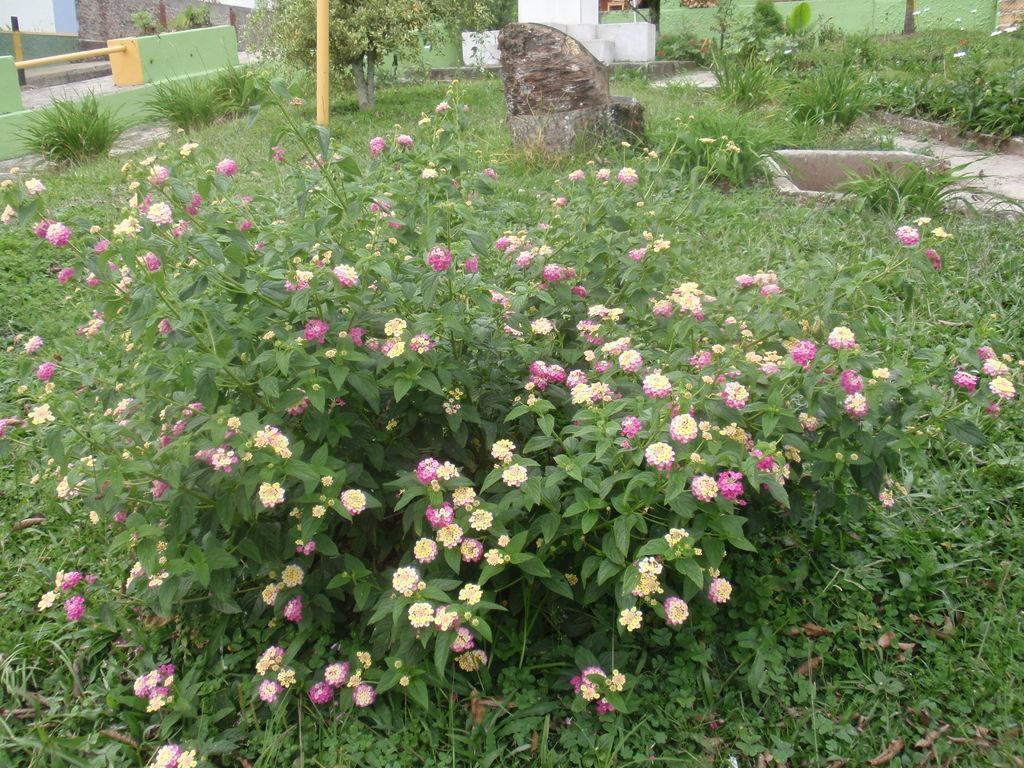What types of vegetation can be seen in the front of the image? There are plants and flowers in the front of the image. What is visible in the background of the image? There is a wall in the background of the image. What can be found in the middle of the image? There is a pole in the middle of the image. Where is the rod located in the image? The rod is on the left side of the image. How many fingers can be seen holding the apple in the image? There is no apple or fingers present in the image. Is the door open or closed in the image? There is no door present in the image. 